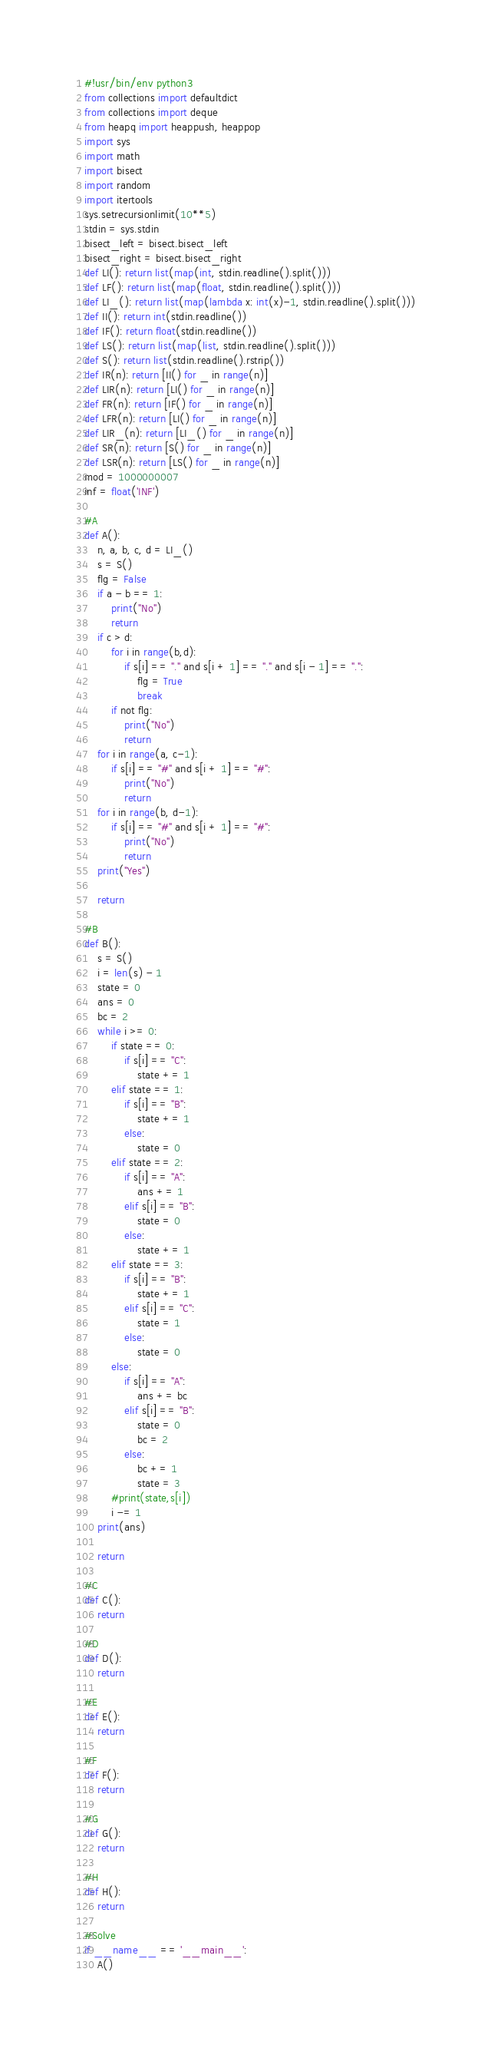Convert code to text. <code><loc_0><loc_0><loc_500><loc_500><_Python_>#!usr/bin/env python3
from collections import defaultdict
from collections import deque
from heapq import heappush, heappop
import sys
import math
import bisect
import random
import itertools
sys.setrecursionlimit(10**5)
stdin = sys.stdin
bisect_left = bisect.bisect_left
bisect_right = bisect.bisect_right
def LI(): return list(map(int, stdin.readline().split()))
def LF(): return list(map(float, stdin.readline().split()))
def LI_(): return list(map(lambda x: int(x)-1, stdin.readline().split()))
def II(): return int(stdin.readline())
def IF(): return float(stdin.readline())
def LS(): return list(map(list, stdin.readline().split()))
def S(): return list(stdin.readline().rstrip())
def IR(n): return [II() for _ in range(n)]
def LIR(n): return [LI() for _ in range(n)]
def FR(n): return [IF() for _ in range(n)]
def LFR(n): return [LI() for _ in range(n)]
def LIR_(n): return [LI_() for _ in range(n)]
def SR(n): return [S() for _ in range(n)]
def LSR(n): return [LS() for _ in range(n)]
mod = 1000000007
inf = float('INF')

#A
def A():
    n, a, b, c, d = LI_()
    s = S()
    flg = False
    if a - b == 1:
        print("No")
        return
    if c > d:
        for i in range(b,d):
            if s[i] == "." and s[i + 1] == "." and s[i - 1] == ".":
                flg = True
                break
        if not flg:
            print("No")
            return
    for i in range(a, c-1):
        if s[i] == "#" and s[i + 1] == "#":
            print("No")
            return
    for i in range(b, d-1):
        if s[i] == "#" and s[i + 1] == "#":
            print("No")
            return
    print("Yes")
    
    return

#B
def B():
    s = S()
    i = len(s) - 1
    state = 0
    ans = 0
    bc = 2
    while i >= 0:
        if state == 0:
            if s[i] == "C":
                state += 1
        elif state == 1:
            if s[i] == "B":
                state += 1
            else:
                state = 0
        elif state == 2:
            if s[i] == "A":
                ans += 1
            elif s[i] == "B":
                state = 0
            else:
                state += 1
        elif state == 3:
            if s[i] == "B":
                state += 1
            elif s[i] == "C":
                state = 1
            else:
                state = 0
        else:
            if s[i] == "A":
                ans += bc
            elif s[i] == "B":
                state = 0
                bc = 2
            else:
                bc += 1
                state = 3
        #print(state,s[i])
        i -= 1
    print(ans)

    return

#C
def C():
    return

#D
def D():
    return

#E
def E():
    return

#F
def F():
    return

#G
def G():
    return

#H
def H():
    return

#Solve
if __name__ == '__main__':
    A()
</code> 